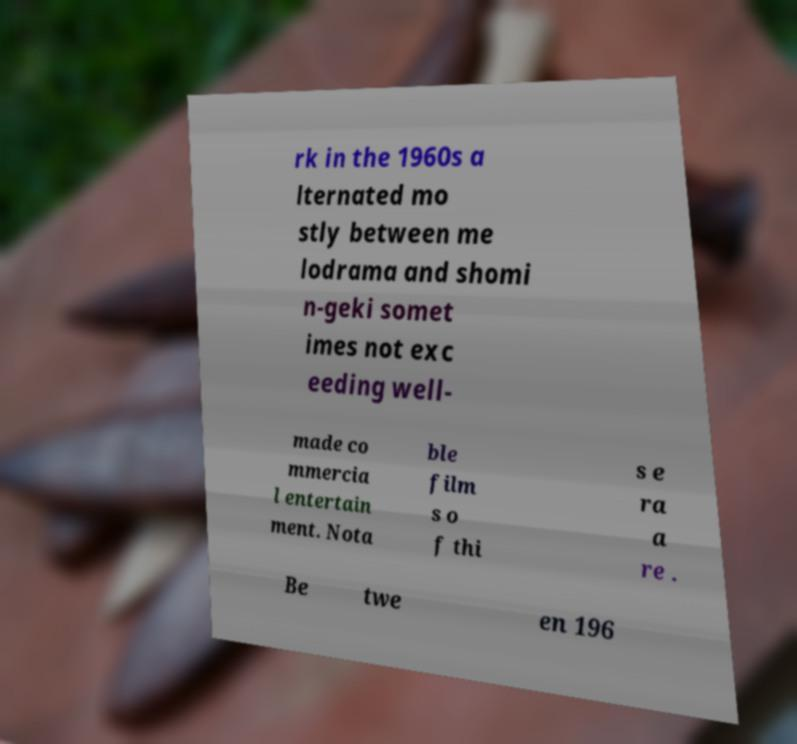For documentation purposes, I need the text within this image transcribed. Could you provide that? rk in the 1960s a lternated mo stly between me lodrama and shomi n-geki somet imes not exc eeding well- made co mmercia l entertain ment. Nota ble film s o f thi s e ra a re . Be twe en 196 